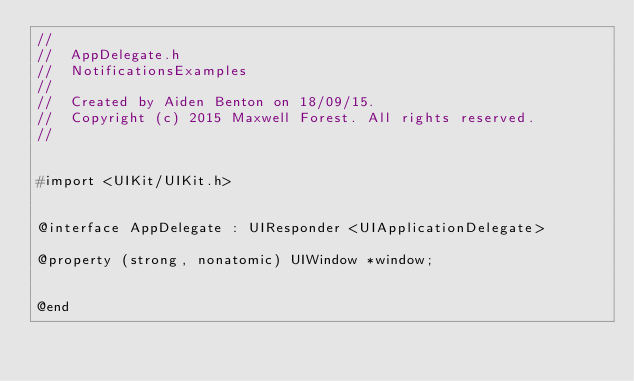<code> <loc_0><loc_0><loc_500><loc_500><_C_>//
//  AppDelegate.h
//  NotificationsExamples
//
//  Created by Aiden Benton on 18/09/15.
//  Copyright (c) 2015 Maxwell Forest. All rights reserved.
//


#import <UIKit/UIKit.h>


@interface AppDelegate : UIResponder <UIApplicationDelegate>

@property (strong, nonatomic) UIWindow *window;


@end
</code> 